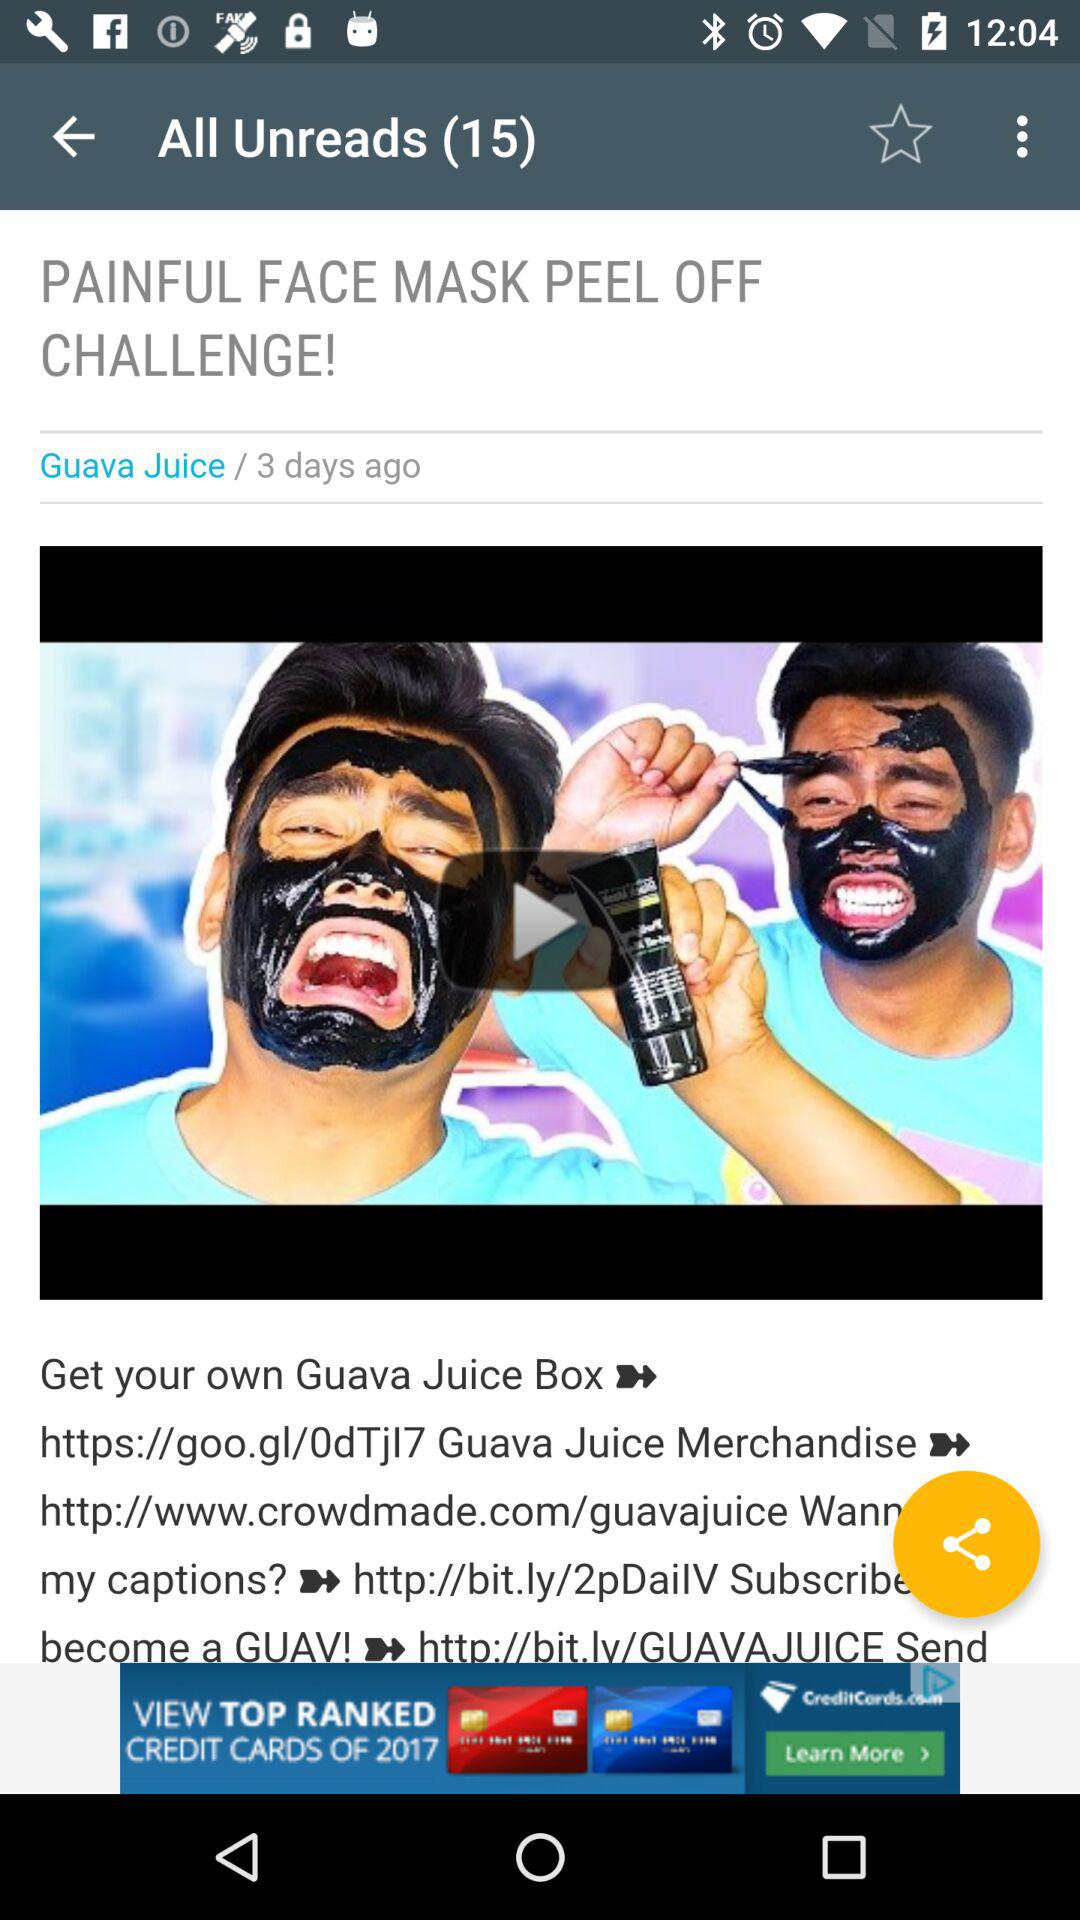How many unread notifications are there? There are 15 unread notifications. 